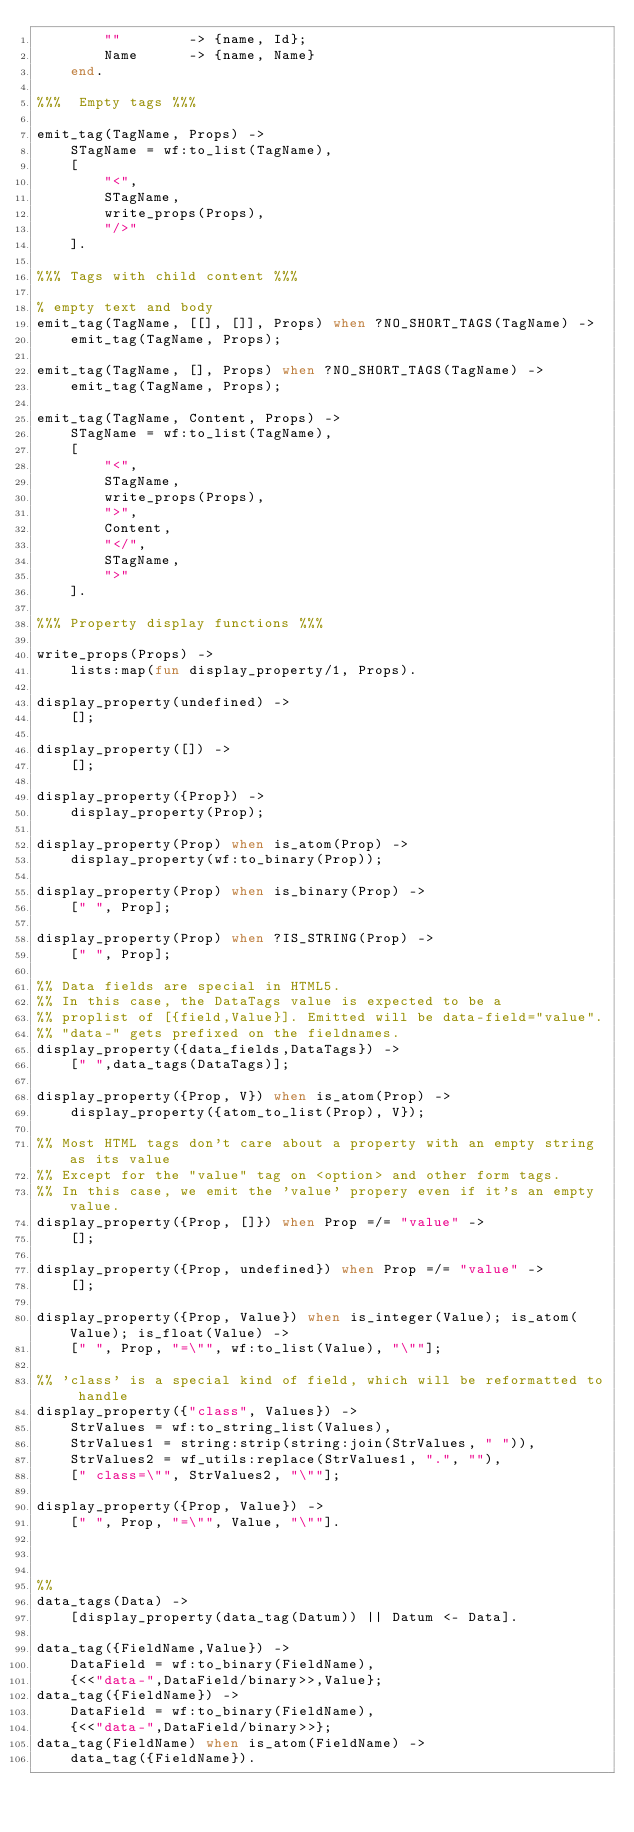<code> <loc_0><loc_0><loc_500><loc_500><_Erlang_>        ""        -> {name, Id};
        Name      -> {name, Name}
    end.

%%%  Empty tags %%%

emit_tag(TagName, Props) ->
    STagName = wf:to_list(TagName),
    [
        "<",
        STagName,
        write_props(Props),
        "/>"
    ].

%%% Tags with child content %%%

% empty text and body
emit_tag(TagName, [[], []], Props) when ?NO_SHORT_TAGS(TagName) ->
    emit_tag(TagName, Props);

emit_tag(TagName, [], Props) when ?NO_SHORT_TAGS(TagName) ->
    emit_tag(TagName, Props);

emit_tag(TagName, Content, Props) ->
    STagName = wf:to_list(TagName),
    [
        "<", 
        STagName, 
        write_props(Props), 
        ">", 
        Content,
        "</", 
        STagName, 
        ">"
    ].    

%%% Property display functions %%%

write_props(Props) ->
    lists:map(fun display_property/1, Props).

display_property(undefined) ->
    [];

display_property([]) ->
    [];

display_property({Prop}) ->
    display_property(Prop);

display_property(Prop) when is_atom(Prop) ->
    display_property(wf:to_binary(Prop));

display_property(Prop) when is_binary(Prop) ->
    [" ", Prop];

display_property(Prop) when ?IS_STRING(Prop) ->
    [" ", Prop];

%% Data fields are special in HTML5.
%% In this case, the DataTags value is expected to be a
%% proplist of [{field,Value}]. Emitted will be data-field="value".
%% "data-" gets prefixed on the fieldnames.
display_property({data_fields,DataTags}) ->
    [" ",data_tags(DataTags)];

display_property({Prop, V}) when is_atom(Prop) ->
    display_property({atom_to_list(Prop), V});

%% Most HTML tags don't care about a property with an empty string as its value
%% Except for the "value" tag on <option> and other form tags.
%% In this case, we emit the 'value' propery even if it's an empty value.
display_property({Prop, []}) when Prop =/= "value" ->
    [];

display_property({Prop, undefined}) when Prop =/= "value" ->
    [];    

display_property({Prop, Value}) when is_integer(Value); is_atom(Value); is_float(Value) ->
    [" ", Prop, "=\"", wf:to_list(Value), "\""];

%% 'class' is a special kind of field, which will be reformatted to handle
display_property({"class", Values}) ->
    StrValues = wf:to_string_list(Values),
    StrValues1 = string:strip(string:join(StrValues, " ")),
    StrValues2 = wf_utils:replace(StrValues1, ".", ""),
    [" class=\"", StrValues2, "\""];

display_property({Prop, Value}) ->
    [" ", Prop, "=\"", Value, "\""].



%% 
data_tags(Data) ->
    [display_property(data_tag(Datum)) || Datum <- Data].

data_tag({FieldName,Value}) ->
    DataField = wf:to_binary(FieldName),
    {<<"data-",DataField/binary>>,Value};
data_tag({FieldName}) ->
    DataField = wf:to_binary(FieldName),
    {<<"data-",DataField/binary>>};
data_tag(FieldName) when is_atom(FieldName) ->
    data_tag({FieldName}).
</code> 